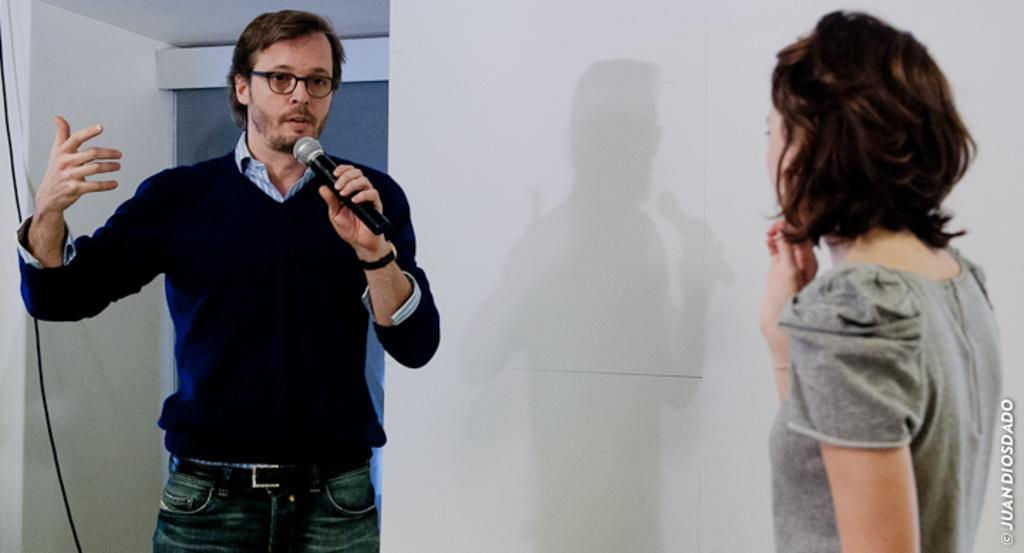What is the person in the image wearing? The person in the image is wearing a blue dress. What is the person in the blue dress doing in the image? The person is standing and speaking in front of a mic. Can you describe the other woman in the image? There is another woman standing in the right corner of the image. What is the color of the background in the image? The background is white in color. What type of boot is the person wearing in the image? The person in the image is not wearing any boots; they are wearing a blue dress. What school is the person speaking at in the image? There is no information about a school in the image; it only shows a person standing and speaking in front of a mic. 